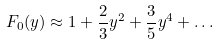Convert formula to latex. <formula><loc_0><loc_0><loc_500><loc_500>F _ { 0 } ( y ) \approx 1 + \frac { 2 } { 3 } y ^ { 2 } + \frac { 3 } { 5 } y ^ { 4 } + \dots</formula> 